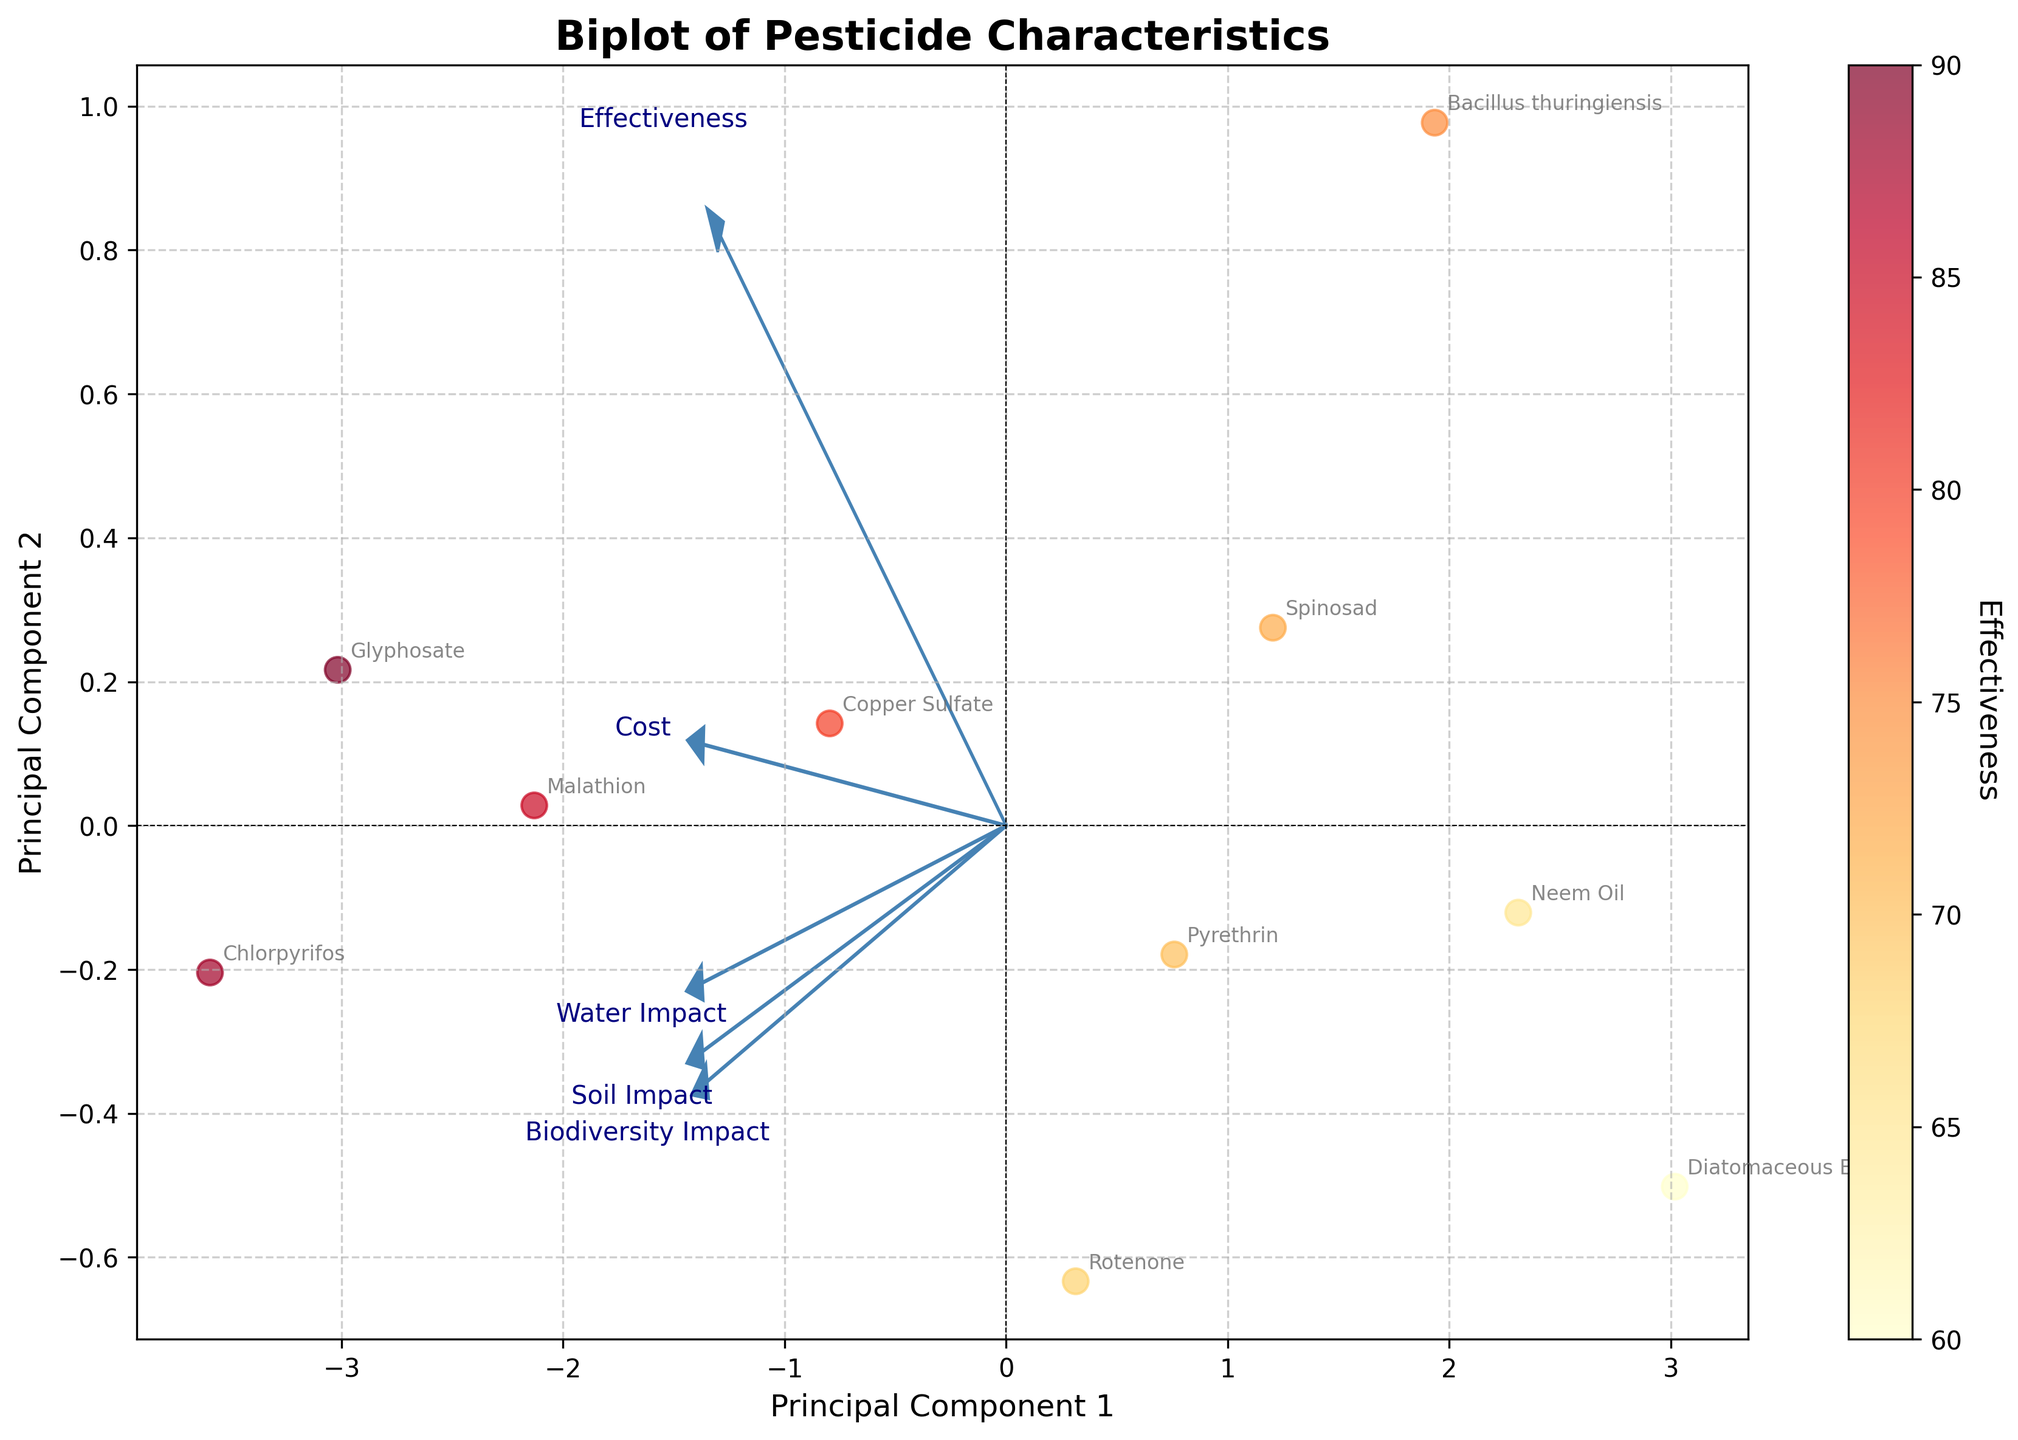What is the title of the figure? The title of the figure can be found at the top center of the plot. It provides a summary of what the figure represents. In this case, the title is "Biplot of Pesticide Characteristics."
Answer: Biplot of Pesticide Characteristics How many pesticides are analyzed in the figure? By counting the number of distinct data points (each representing a different pesticide) and their corresponding labels on the plot, we can determine the number of pesticides analyzed. There are 10 pesticides labeled in the plot.
Answer: 10 Which pesticide is the most effective according to the plot? Effectiveness is represented by the color intensity in the scatter plot. The most effective pesticide will have the darkest (reddish) color. Glyphosate has the darkest color representing the highest effectiveness.
Answer: Glyphosate Which two features have the largest impact on Principal Component 1? The features are represented by arrows, and their impact on Principal Component 1 (PC1) is proportional to the length of the arrow along the PC1 axis. Observe which arrows are longest along the PC1 axis. "Effectiveness" and "Biodiversity Impact" have the largest arrows along PC1.
Answer: Effectiveness and Biodiversity Impact What pesticide has the highest Soil Impact and how is it indicated in the biplot? Soil Impact can be deduced from the position of the data points in the direction of the Soil Impact arrow. The pesticide closest to the tip of the Soil Impact arrow is likely Chlorpyrifos, indicating the highest Soil Impact.
Answer: Chlorpyrifos Compare Neem Oil and Malathion in terms of their positions on Principal Component 1 and Principal Component 2. Which is more effective? Locate Neem Oil and Malathion on the plot by their labels. Assess their positions on the PC1 and PC2 axes. Malathion is farther to the right along PC1, which represents higher effectiveness.
Answer: Malathion Which feature has the least contribution to Principal Component 2? Identify the feature arrows and observe which one is shortest along the PC2 axis. The shortest arrow along the PC2 axis represents the least contribution. "Cost" has the least contribution as it is nearly parallel to the PC1 axis.
Answer: Cost Is there a visible trade-off between effectiveness and soil impact in the biplot? Examine the direction and position of the "Effectiveness" and "Soil Impact" arrows. If they are pointing in opposite directions or if there is a negative correlation in the positions of pesticides, a trade-off is likely. The arrows for Effectiveness and Soil Impact point roughly in opposite directions, indicating a trade-off.
Answer: Yes How does Diatomaceous Earth compare to Copper Sulfate in terms of biodiversity impact? Find the positions of Diatomaceous Earth and Copper Sulfate relative to the Biodiversity Impact arrow. Copper Sulfate is farther along the Biodiversity Impact arrow compared to Diatomaceous Earth, indicating higher biodiversity impact.
Answer: Copper Sulfate Which pesticides are grouped closely together in the biplot, and what does this imply about their characteristics? Identify clusters of data points in the biplot. Pesticides that are close to each other likely have similar characteristics. Neem Oil and Diatomaceous Earth are close to each other, implying similar characteristics in terms of the analyzed features.
Answer: Neem Oil and Diatomaceous Earth 